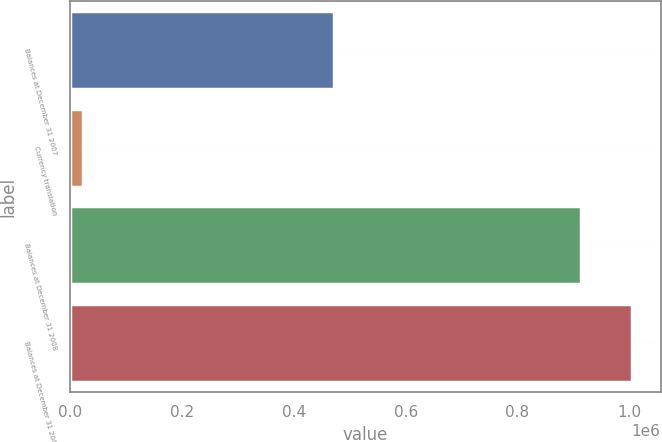Convert chart to OTSL. <chart><loc_0><loc_0><loc_500><loc_500><bar_chart><fcel>Balances at December 31 2007<fcel>Currency translation<fcel>Balances at December 31 2008<fcel>Balances at December 31 2009<nl><fcel>471866<fcel>21677<fcel>913057<fcel>1.00593e+06<nl></chart> 